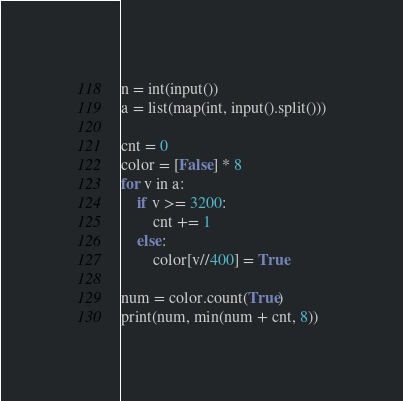<code> <loc_0><loc_0><loc_500><loc_500><_Python_>n = int(input())
a = list(map(int, input().split()))

cnt = 0
color = [False] * 8
for v in a:
    if v >= 3200:
        cnt += 1
    else:
        color[v//400] = True

num = color.count(True)
print(num, min(num + cnt, 8))</code> 